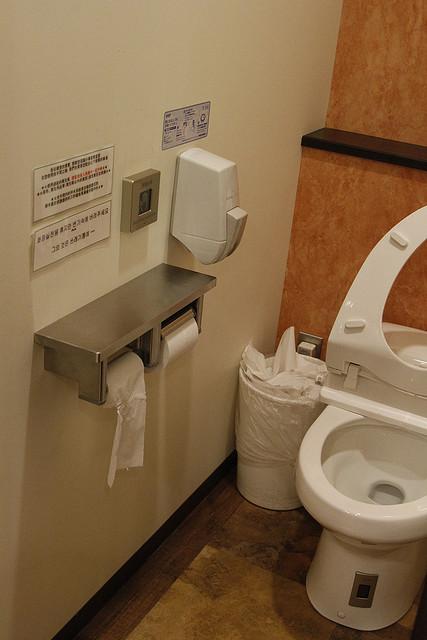What type of establishment could this bathroom be in?
Keep it brief. Restaurant. What is going on in this picture that'S bad for the environment?
Give a very brief answer. Waste. How many rolls of toilet paper are there?
Give a very brief answer. 2. In what side is the trash can?
Concise answer only. Left. Is the bathroom out of toilet paper?
Keep it brief. No. Is the toilet seat up?
Write a very short answer. Yes. Is this toilet operating properly?
Quick response, please. Yes. Is the toilet seat up or down?
Short answer required. Up. What do you do in this room?
Short answer required. Use toilet. Who used the toilet last?
Keep it brief. Man. What word do you see clearly on the sign over the toilet?
Answer briefly. Wash hands. Is this a full bathroom?
Be succinct. No. Does the waste bin need to be emptied?
Be succinct. Yes. 